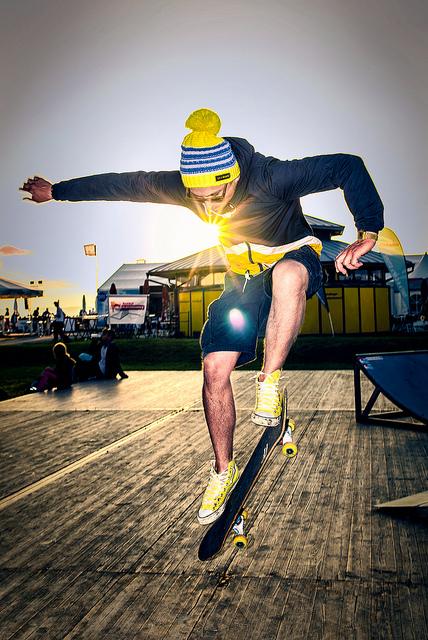Does the hat have a yellow ball on the top?
Be succinct. Yes. What sport is being done?
Write a very short answer. Skateboarding. Is the man skateboarding on a boardwalk?
Quick response, please. Yes. 